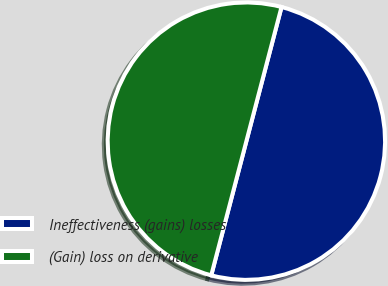<chart> <loc_0><loc_0><loc_500><loc_500><pie_chart><fcel>Ineffectiveness (gains) losses<fcel>(Gain) loss on derivative<nl><fcel>50.0%<fcel>50.0%<nl></chart> 